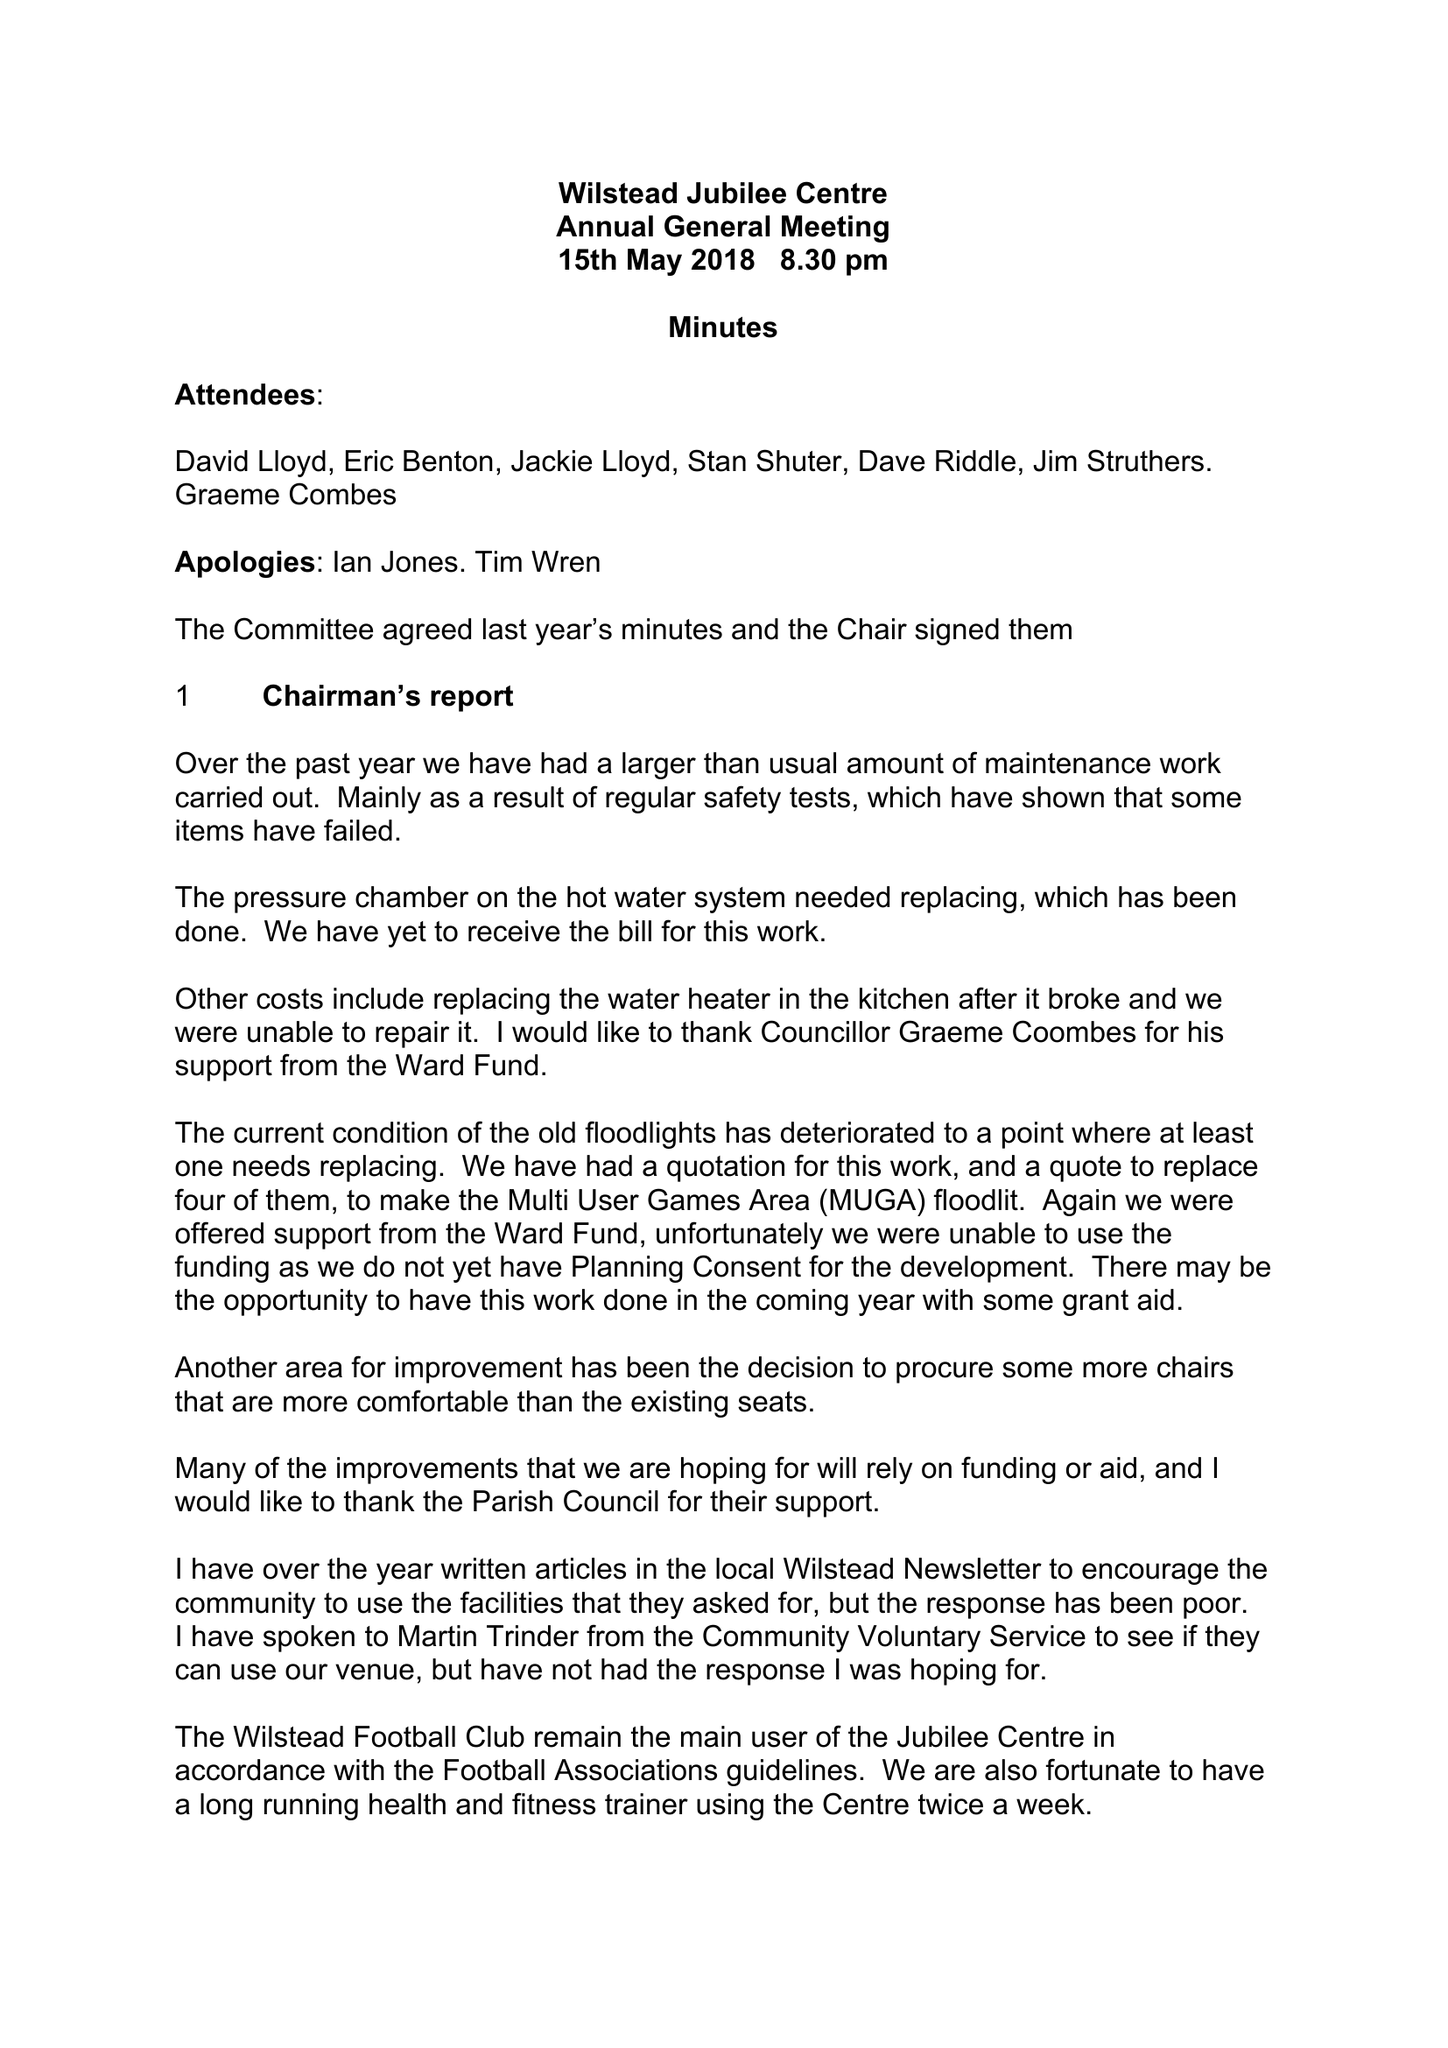What is the value for the charity_number?
Answer the question using a single word or phrase. 1162106 